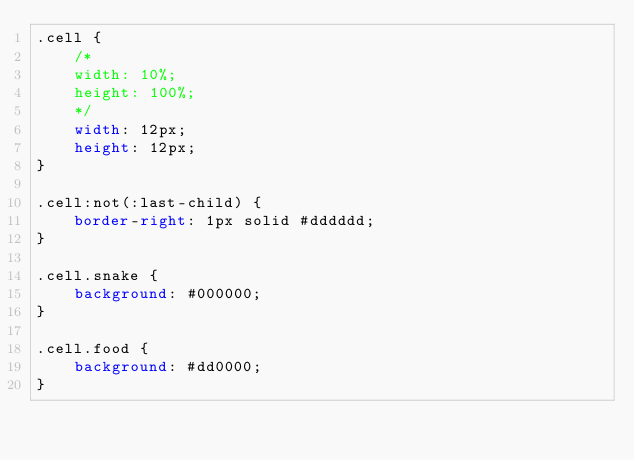<code> <loc_0><loc_0><loc_500><loc_500><_CSS_>.cell {
    /*
    width: 10%;
    height: 100%;
    */
    width: 12px;
    height: 12px;
}

.cell:not(:last-child) {
    border-right: 1px solid #dddddd;
}

.cell.snake {
    background: #000000;
}

.cell.food {
    background: #dd0000;
}
</code> 